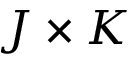Convert formula to latex. <formula><loc_0><loc_0><loc_500><loc_500>J \times K</formula> 